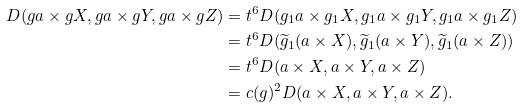<formula> <loc_0><loc_0><loc_500><loc_500>D ( g a \times g X , g a \times g Y , g a \times g Z ) & = t ^ { 6 } D ( g _ { 1 } a \times g _ { 1 } X , g _ { 1 } a \times g _ { 1 } Y , g _ { 1 } a \times g _ { 1 } Z ) \\ & = t ^ { 6 } D ( \widetilde { g } _ { 1 } ( a \times X ) , \widetilde { g } _ { 1 } ( a \times Y ) , \widetilde { g } _ { 1 } ( a \times Z ) ) \\ & = t ^ { 6 } D ( a \times X , a \times Y , a \times Z ) \\ & = c ( g ) ^ { 2 } D ( a \times X , a \times Y , a \times Z ) .</formula> 